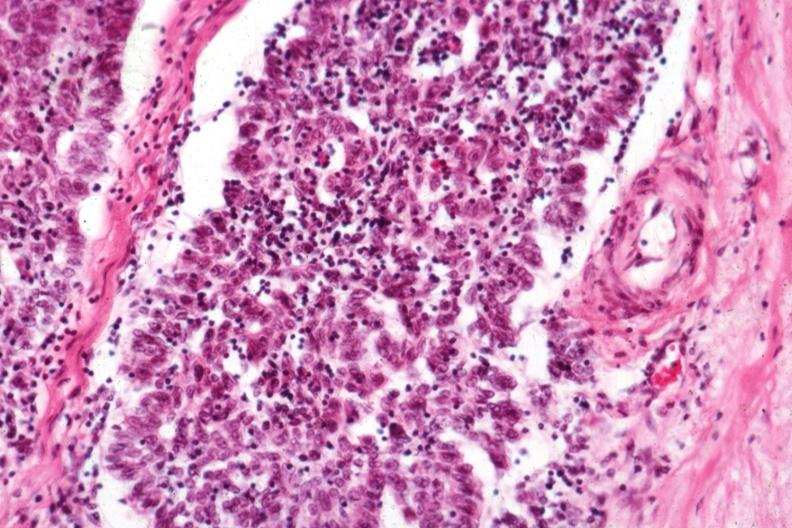s thymus present?
Answer the question using a single word or phrase. Yes 